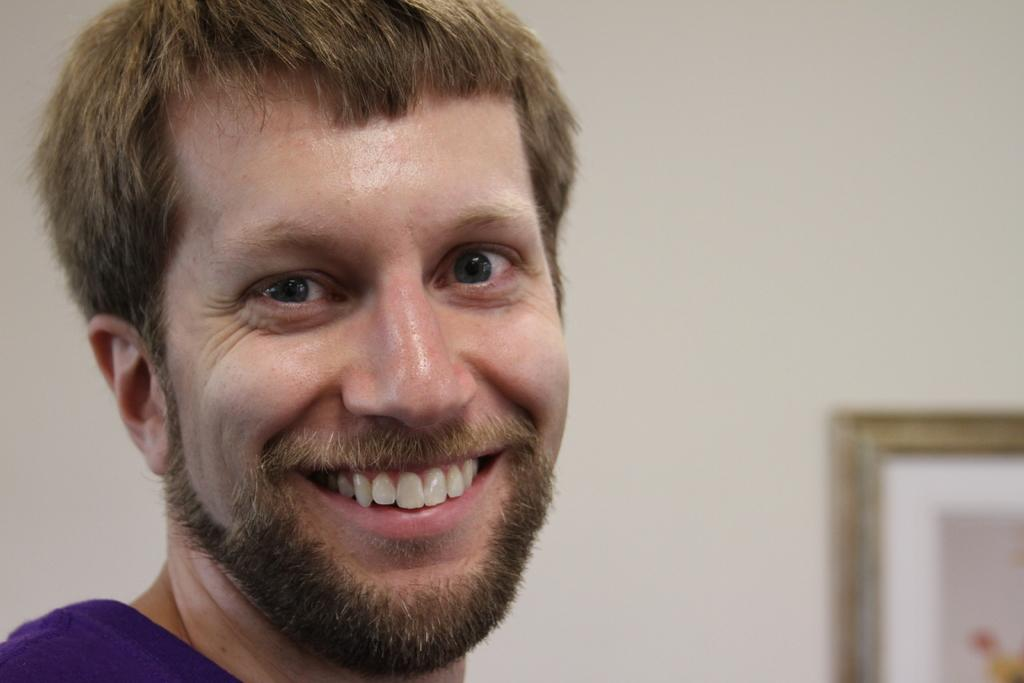Who is present in the image? There is a man in the image. What is the man's facial expression? The man is smiling. What can be seen on the wall in the background of the image? There is a frame on the wall in the background of the image. What type of vacation is the man planning based on his apparel in the image? There is no information about the man's apparel or any vacation plans in the image. 